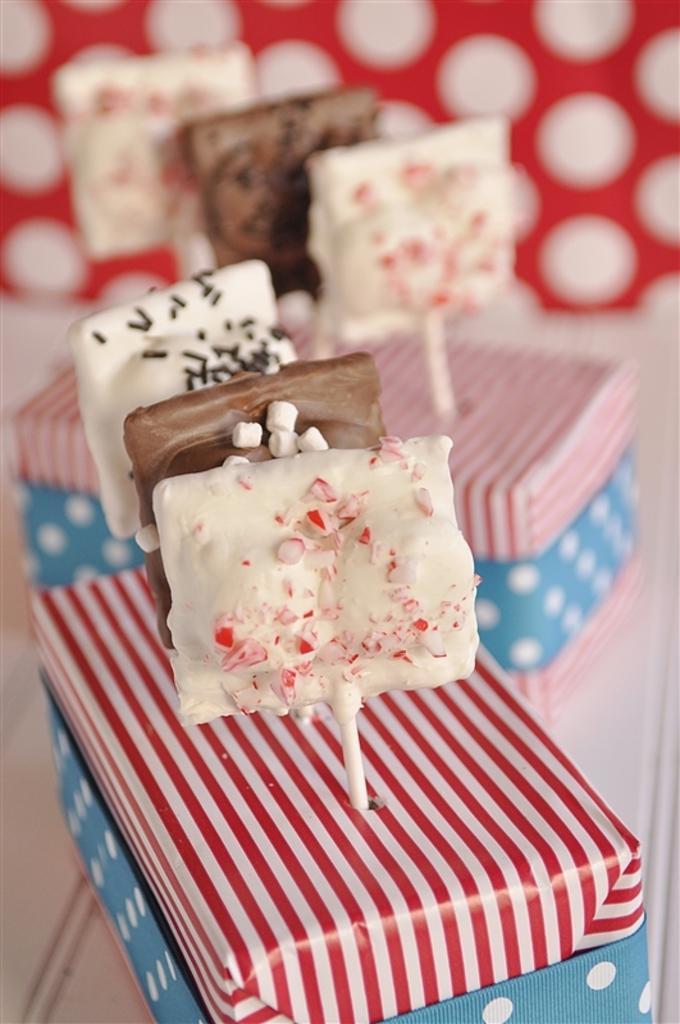Can you describe this image briefly? In this picture I can see there is some candies placed in a box and there is another box in the backdrop, there is a red color wall with polka dots. 